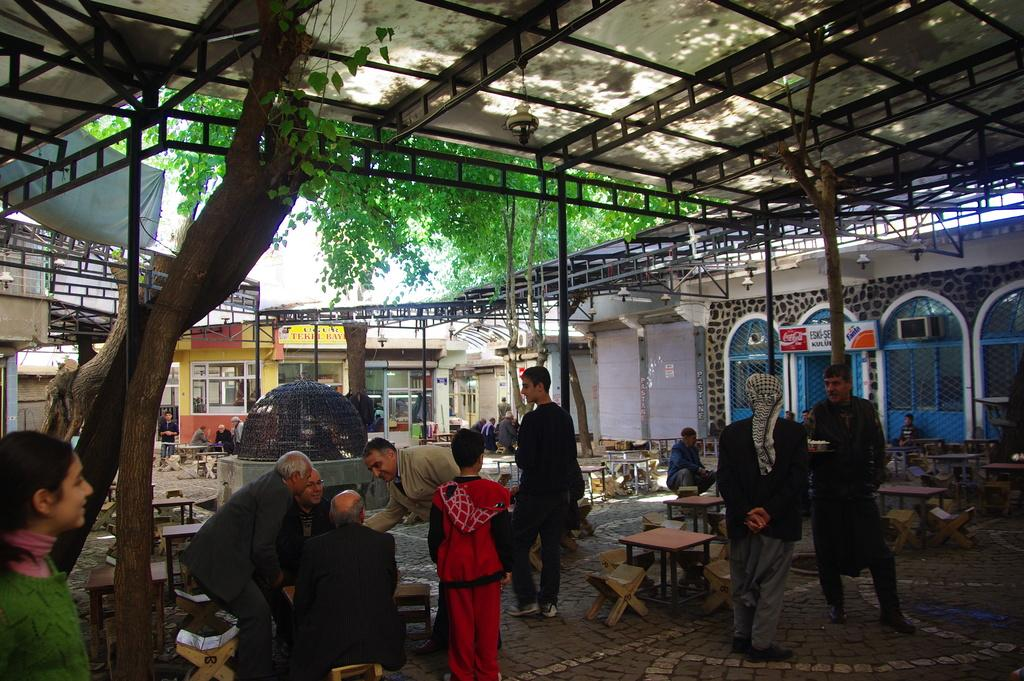How many people are present in the image? There are many people in the image. What are the people wearing? The people are wearing clothes. What type of furniture is present in the image? There are stools and a table in the image. What part of the building can be seen in the image? There is a window in the building visible in the image. What type of vegetation is present in the image? There is a tree in the image. What architectural feature is present in the image? There is a pole in the image. What part of the natural environment is visible in the image? The sky is visible in the image. How many robins are sitting on the pole in the image? There are no robins present in the image; only people, stools, a table, a building, a window, a tree, and a pole are visible. Are the people in the image brothers? There is no information provided about the relationships between the people in the image, so it cannot be determined if they are brothers. 